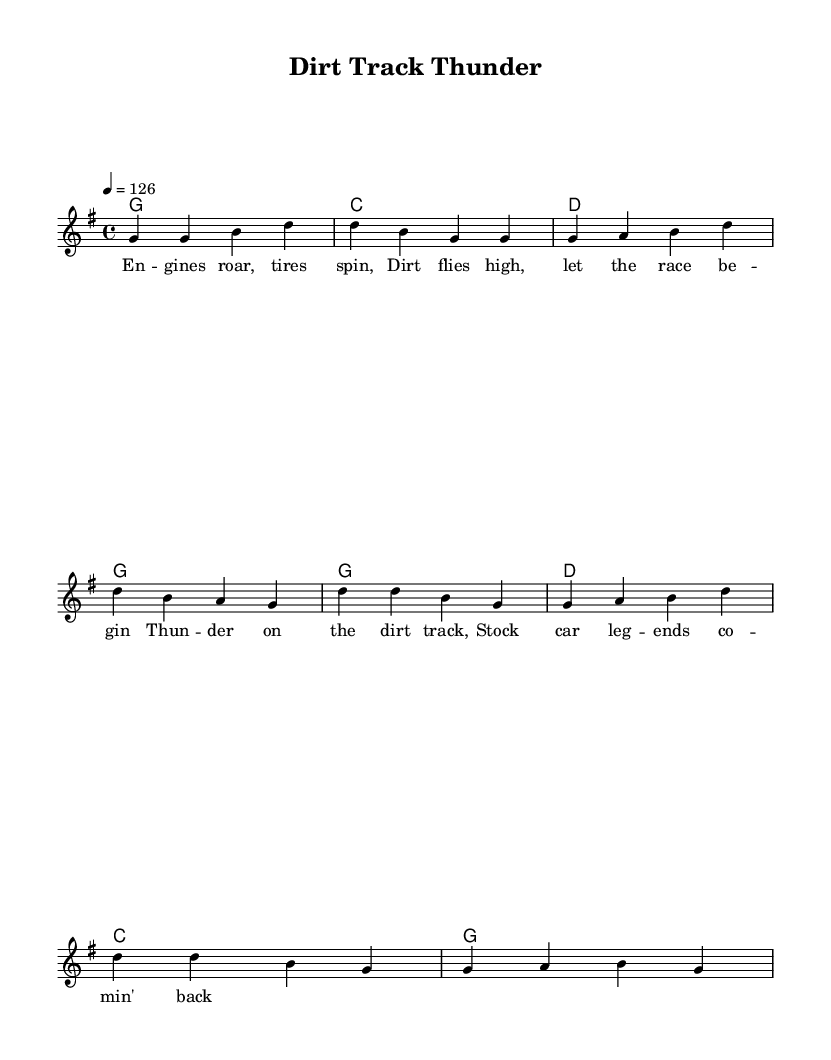What is the key signature of this music? The key signature is G major, which has one sharp (F#). This is identifiable in the global settings where it specifies \key g \major.
Answer: G major What is the time signature of this music? The time signature is 4/4, indicated by the \time 4/4 statement in the global settings. This means there are four beats per measure, and the quarter note gets one beat.
Answer: 4/4 What is the tempo marking for this piece? The tempo marking is 126 beats per minute, indicated by the statement \tempo 4 = 126 in the global settings. This specifies how fast the music should be played.
Answer: 126 How many measures are in the verse section? The verse section consists of four measures, as indicated by the grouping of notes in the melody line, where the first verse lines up with four distinct measures.
Answer: Four What is the overall theme of the lyrics? The overall theme of the lyrics centers around dirt track racing, as expressed in both the verse and chorus, highlighting racing elements such as engines and stock cars.
Answer: Dirt track racing Which section contains the phrase "Thunder on the dirt track"? The phrase "Thunder on the dirt track" is found in the chorus, which is marked distinctly after the verse lines in the lyrics provided.
Answer: Chorus 